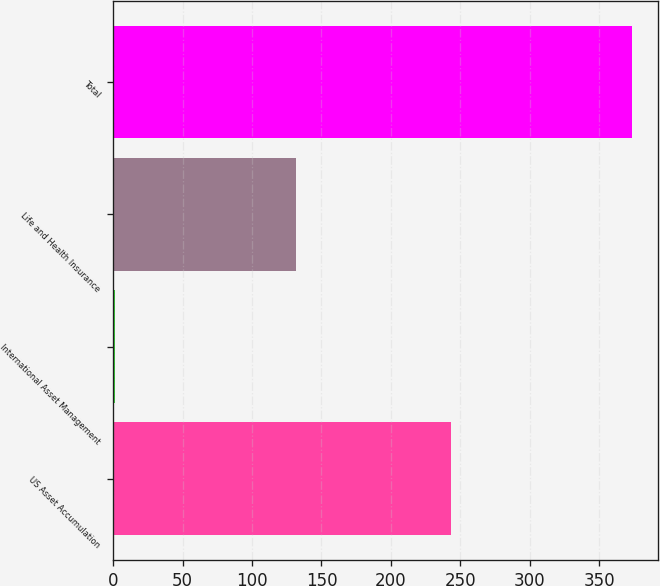Convert chart to OTSL. <chart><loc_0><loc_0><loc_500><loc_500><bar_chart><fcel>US Asset Accumulation<fcel>International Asset Management<fcel>Life and Health Insurance<fcel>Total<nl><fcel>243.1<fcel>1.3<fcel>131.9<fcel>373.7<nl></chart> 